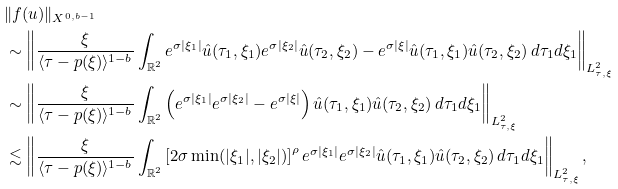Convert formula to latex. <formula><loc_0><loc_0><loc_500><loc_500>& \| f ( u ) \| _ { X ^ { 0 , b - 1 } } \\ & \sim \left \| \frac { \xi } { \langle \tau - p ( \xi ) \rangle ^ { 1 - b } } \int _ { \mathbb { R } ^ { 2 } } e ^ { \sigma | \xi _ { 1 } | } \hat { u } ( \tau _ { 1 } , \xi _ { 1 } ) e ^ { \sigma | \xi _ { 2 } | } \hat { u } ( \tau _ { 2 } , \xi _ { 2 } ) - e ^ { \sigma | \xi | } \hat { u } ( \tau _ { 1 } , \xi _ { 1 } ) \hat { u } ( \tau _ { 2 } , \xi _ { 2 } ) \, d \tau _ { 1 } d \xi _ { 1 } \right \| _ { L ^ { 2 } _ { \tau , \xi } } \\ & \sim \left \| \frac { \xi } { \langle \tau - p ( \xi ) \rangle ^ { 1 - b } } \int _ { \mathbb { R } ^ { 2 } } \left ( e ^ { \sigma | \xi _ { 1 } | } e ^ { \sigma | \xi _ { 2 } | } - e ^ { \sigma | \xi | } \right ) \hat { u } ( \tau _ { 1 } , \xi _ { 1 } ) \hat { u } ( \tau _ { 2 } , \xi _ { 2 } ) \, d \tau _ { 1 } d \xi _ { 1 } \right \| _ { L ^ { 2 } _ { \tau , \xi } } \\ & \lesssim \left \| \frac { \xi } { \langle \tau - p ( \xi ) \rangle ^ { 1 - b } } \int _ { \mathbb { R } ^ { 2 } } \left [ 2 \sigma \min ( | \xi _ { 1 } | , | \xi _ { 2 } | ) \right ] ^ { \rho } e ^ { \sigma | \xi _ { 1 } | } e ^ { \sigma | \xi _ { 2 } | } \hat { u } ( \tau _ { 1 } , \xi _ { 1 } ) \hat { u } ( \tau _ { 2 } , \xi _ { 2 } ) \, d \tau _ { 1 } d \xi _ { 1 } \right \| _ { L ^ { 2 } _ { \tau , \xi } } ,</formula> 